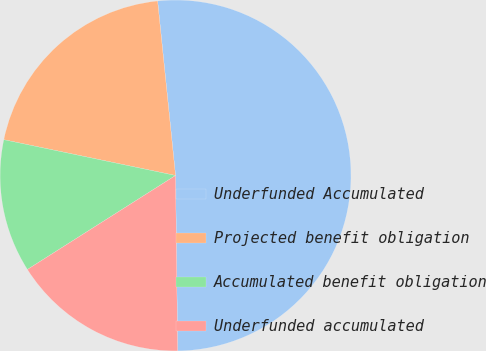Convert chart to OTSL. <chart><loc_0><loc_0><loc_500><loc_500><pie_chart><fcel>Underfunded Accumulated<fcel>Projected benefit obligation<fcel>Accumulated benefit obligation<fcel>Underfunded accumulated<nl><fcel>51.44%<fcel>20.1%<fcel>12.27%<fcel>16.19%<nl></chart> 